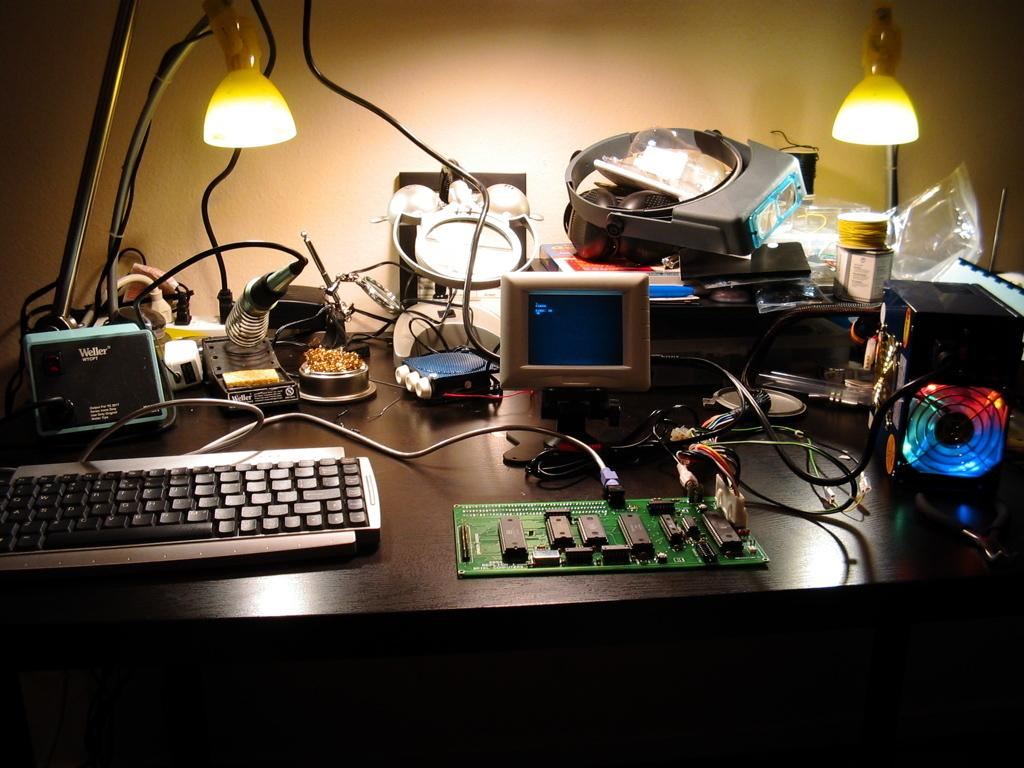What piece of furniture is in the image? There is a table in the image. What is on top of the table? There is a table lamp, a keyboard, a motherboard, and a small monitor on the table. What might be used for illumination in the image? A table lamp is present on the table for illumination. What type of electronic device is visible on the table? A keyboard and a small monitor are visible on the table. How does the motherboard connect to the water in the image? There is no water present in the image, and the motherboard is not connected to any water. 